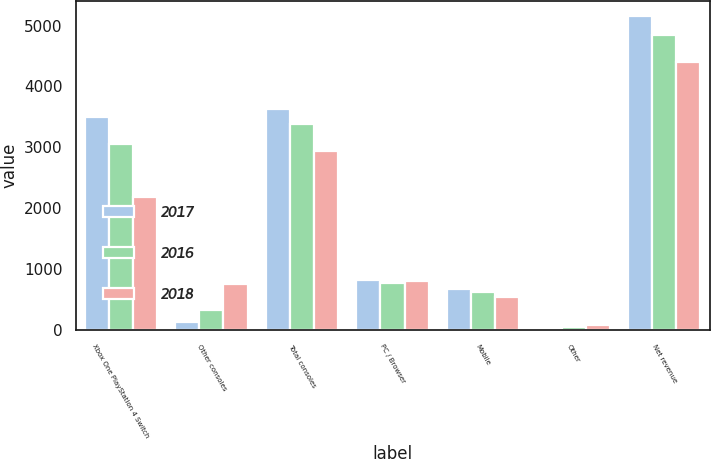Convert chart to OTSL. <chart><loc_0><loc_0><loc_500><loc_500><stacked_bar_chart><ecel><fcel>Xbox One PlayStation 4 Switch<fcel>Other consoles<fcel>Total consoles<fcel>PC / Browser<fcel>Mobile<fcel>Other<fcel>Net revenue<nl><fcel>2017<fcel>3495<fcel>140<fcel>3635<fcel>827<fcel>672<fcel>16<fcel>5150<nl><fcel>2016<fcel>3056<fcel>334<fcel>3390<fcel>773<fcel>627<fcel>55<fcel>4845<nl><fcel>2018<fcel>2183<fcel>759<fcel>2942<fcel>814<fcel>548<fcel>92<fcel>4396<nl></chart> 